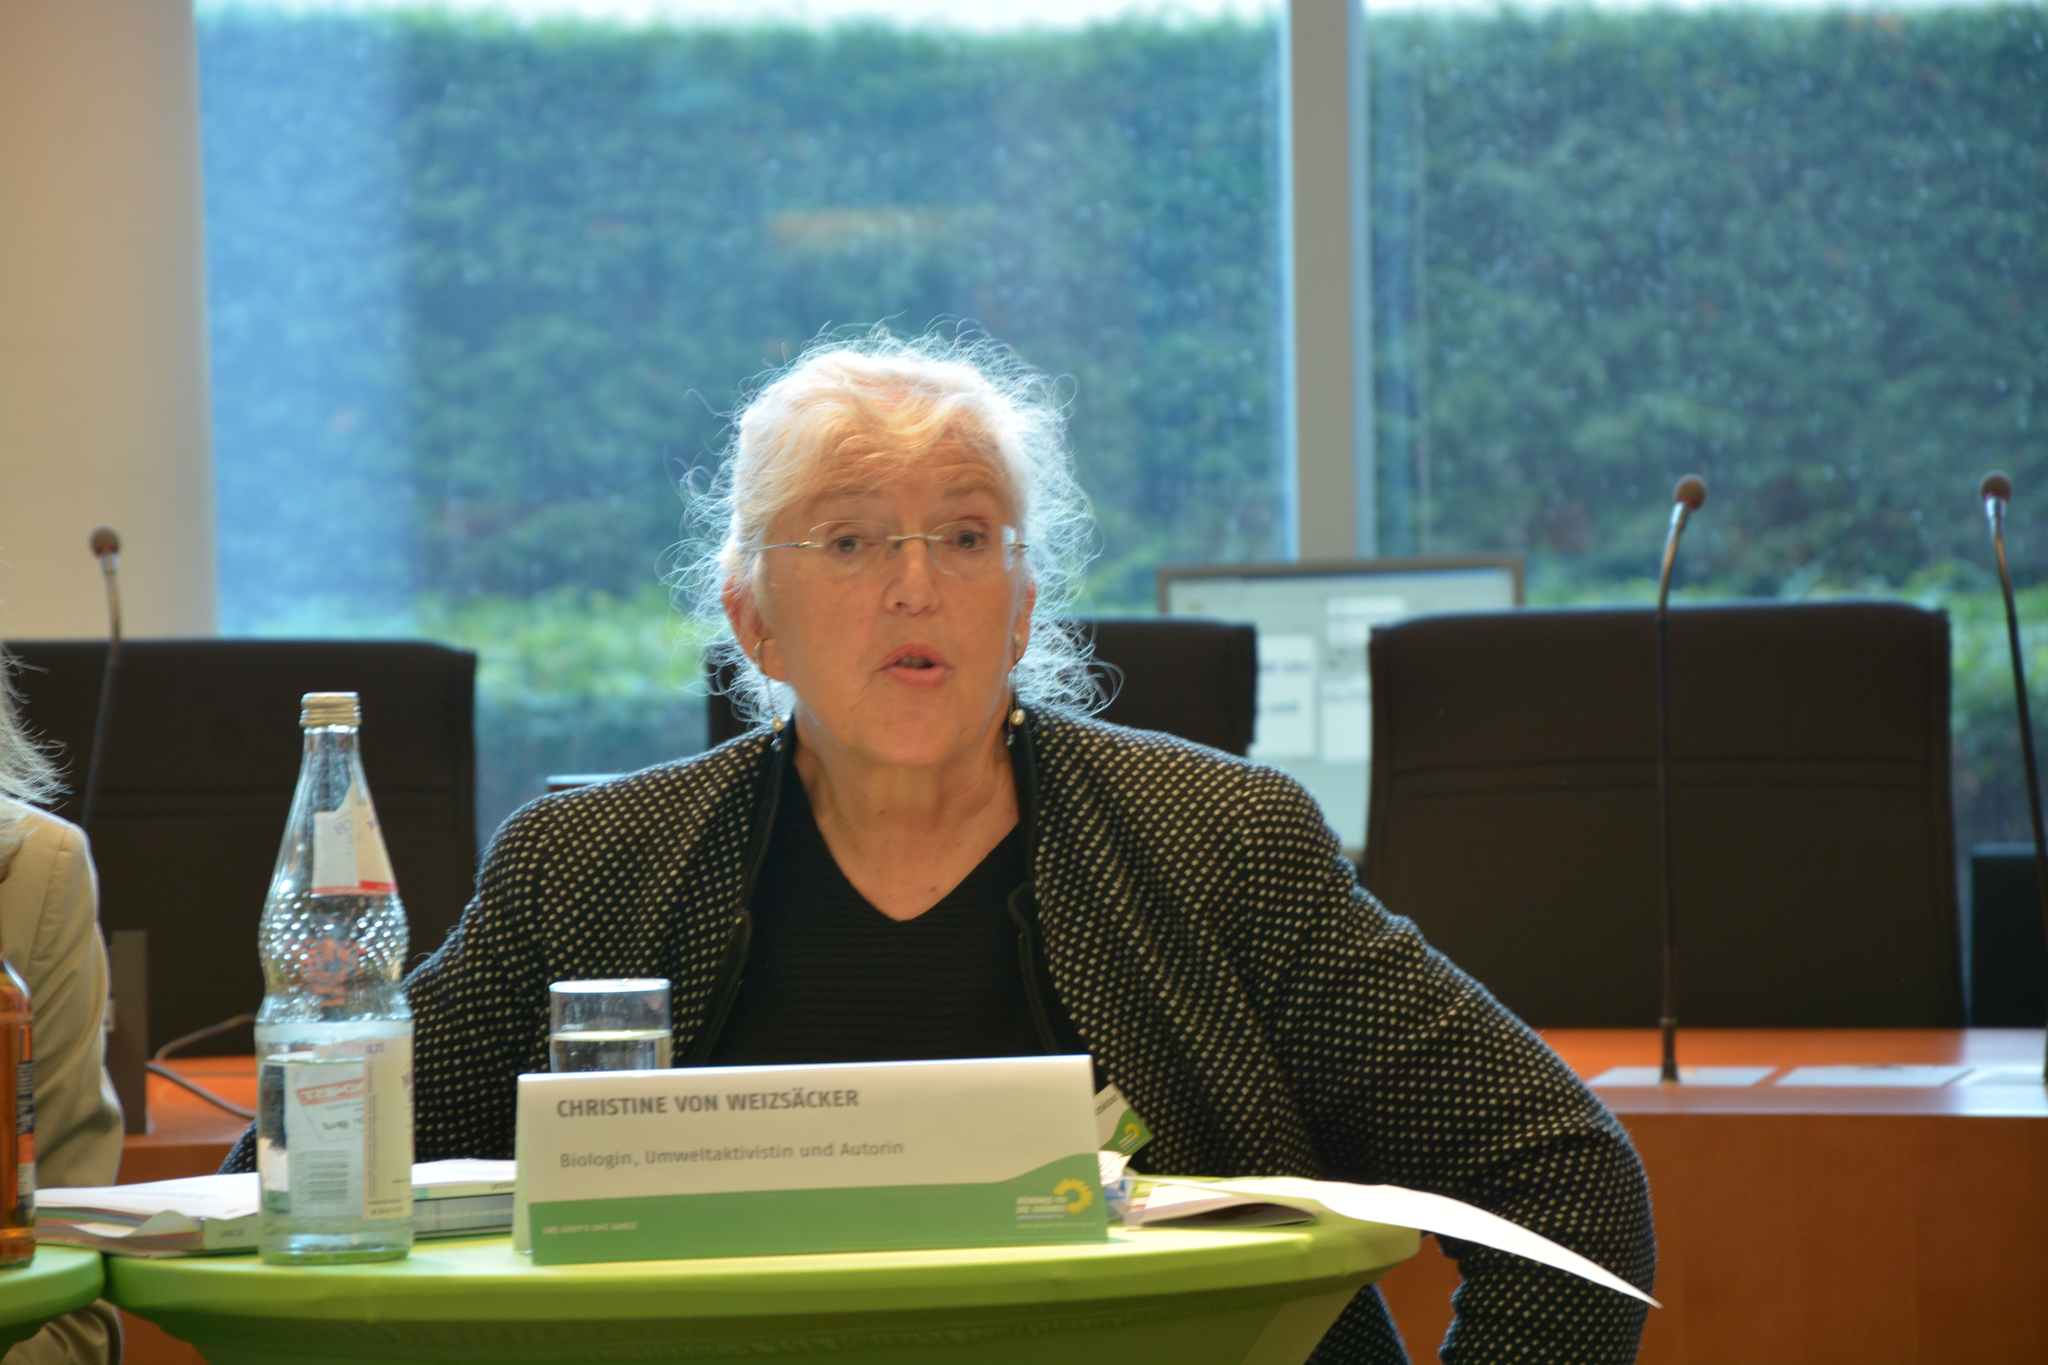Describe this image in one or two sentences. In this image I can see a woman is sitting on a chair. Here I can see a bottle and a glass. In the background I can see few more chairs, mics and a table. 